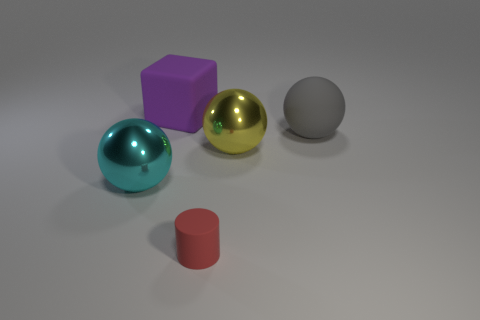If these objects were part of a game, what rules could apply to them? If these objects were elements of a game, one might imagine a set of rules where each shape represents a different value or property. The spheres could be points of varying worth based on their color, the cube might serve as a multiplier, and the cylinder could act as a wildcard. The goal could involve arranging these pieces to maximize points or create specific patterns under a time limit. 